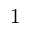Convert formula to latex. <formula><loc_0><loc_0><loc_500><loc_500>1</formula> 